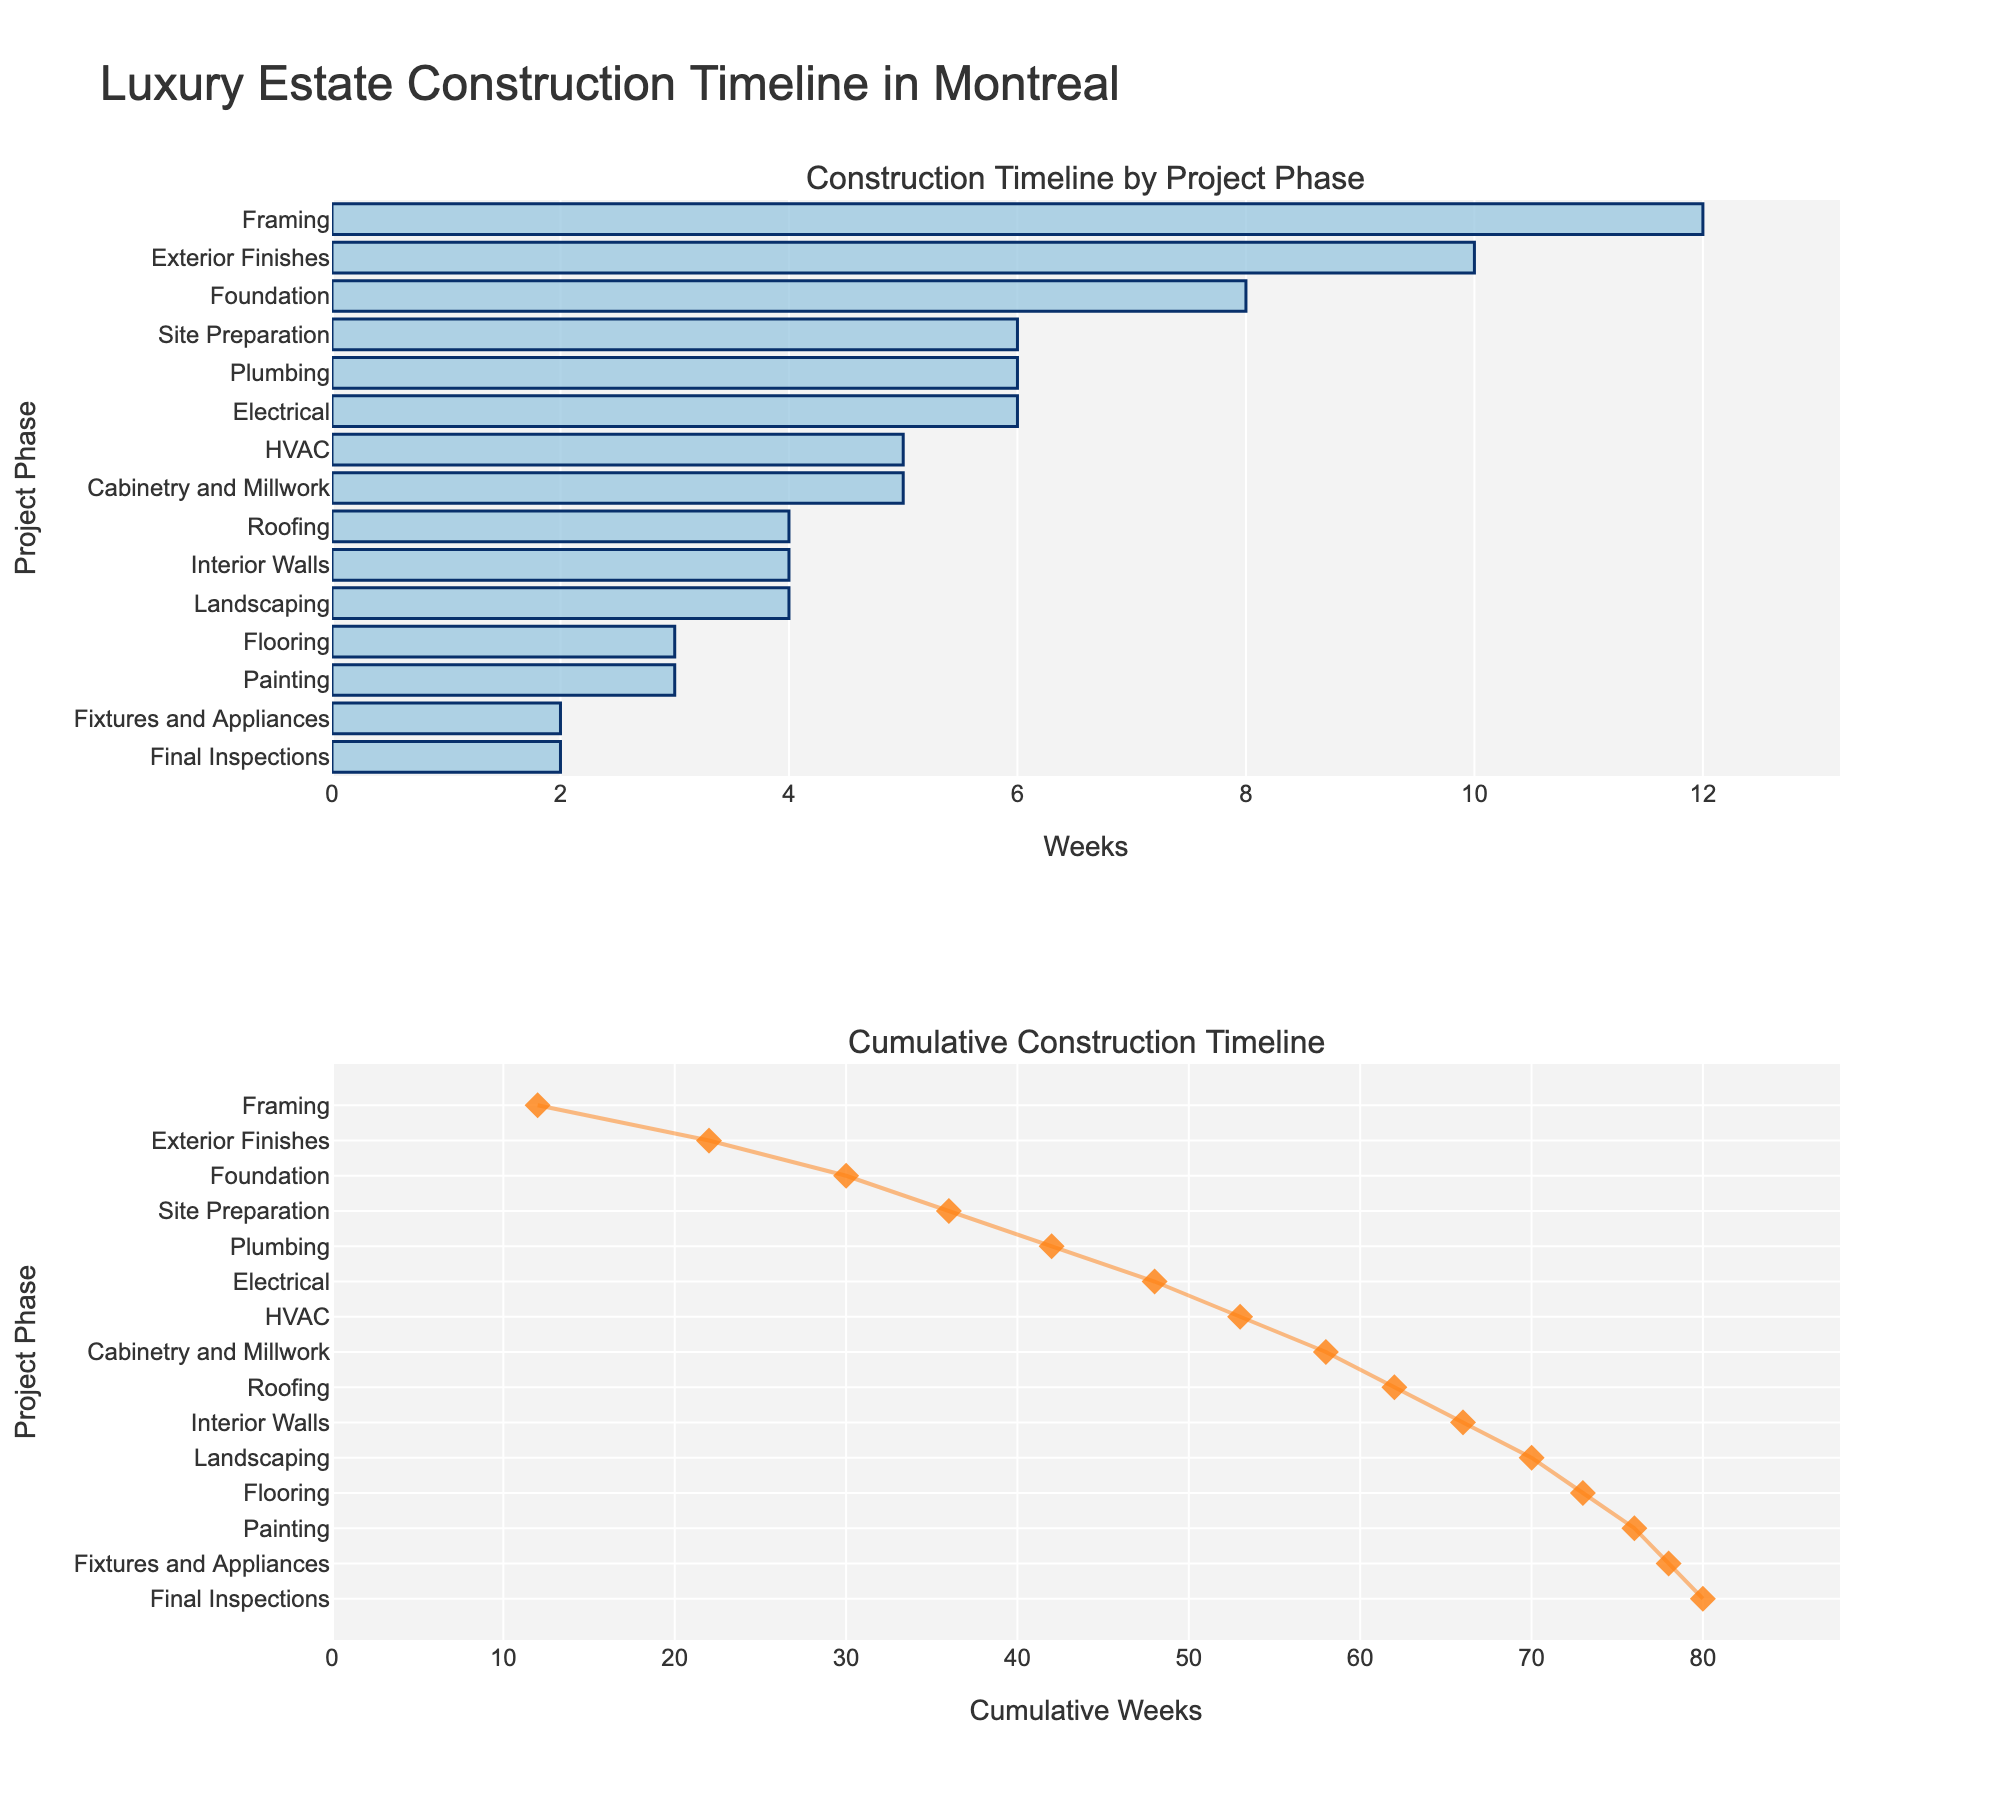What's the title of the figure? The title of the figure is shown at the top center. It reads "Luxury Estate Construction Timeline in Montreal".
Answer: Luxury Estate Construction Timeline in Montreal Which project phase takes the longest time according to the bar chart? Look at the bar chart for the phase with the longest bar. The "Framing" phase has the longest bar.
Answer: Framing How many weeks in total does the "Interior Walls" phase take? Refer to the bar chart and find the "Interior Walls" phase. The bar indicates it takes 4 weeks.
Answer: 4 In the cumulative timeline, which project phase appears last? The last point in the cumulative timeline represents the final phase. It is "Final Inspections".
Answer: Final Inspections Which project phase has the shortest duration? Look for the shortest bar in the bar chart. The "Fixtures and Appliances" phase has the shortest duration.
Answer: Fixtures and Appliances What is the combined duration of the "Plumbing" and "Electrical" phases? The "Plumbing" phase takes 6 weeks and the "Electrical" phase also takes 6 weeks. Summing these, 6 + 6 equals 12 weeks.
Answer: 12 Which project phase immediately follows the longest phase in the cumulative timeline? The longest phase is "Framing" with 12 weeks. In the cumulative timeline, the next phase is "Exterior Finishes".
Answer: Exterior Finishes How many project phases take exactly 4 weeks to complete? Identify bars with a length of 4 weeks in the bar chart. There are 3 such phases: "Roofing", "Interior Walls", and "Landscaping".
Answer: 3 What is the cumulative duration at the "HVAC" phase in the timeline? Find "HVAC" in the cumulative timeline. The duration up to this phase is 41 weeks.
Answer: 41 Compare the durations of "Foundation" and "Cabinetry and Millwork". Which is longer? The "Foundation" phase is 8 weeks while "Cabinetry and Millwork" is 5 weeks. Therefore, "Foundation" is longer.
Answer: Foundation 